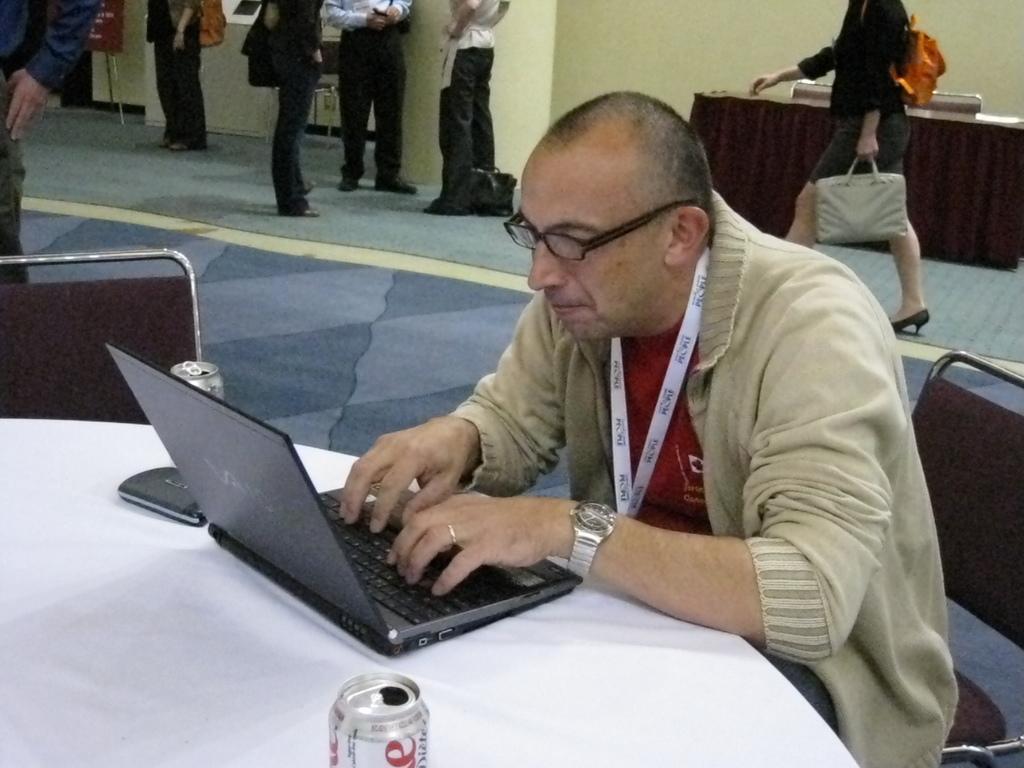Could you give a brief overview of what you see in this image? In the background we can see the wall, table, board, a bag on the floor and few objects. In this picture we can see the people standing. On the right side of the picture we can see a man wearing spectacles, wrist watch and sitting on a chair. He is staring at a laptop and it seems like he is typing. On a table we can see the drinking tins and an object. We can also see a chair. We can see a woman wearing a bag and holding another bag. She is walking. 